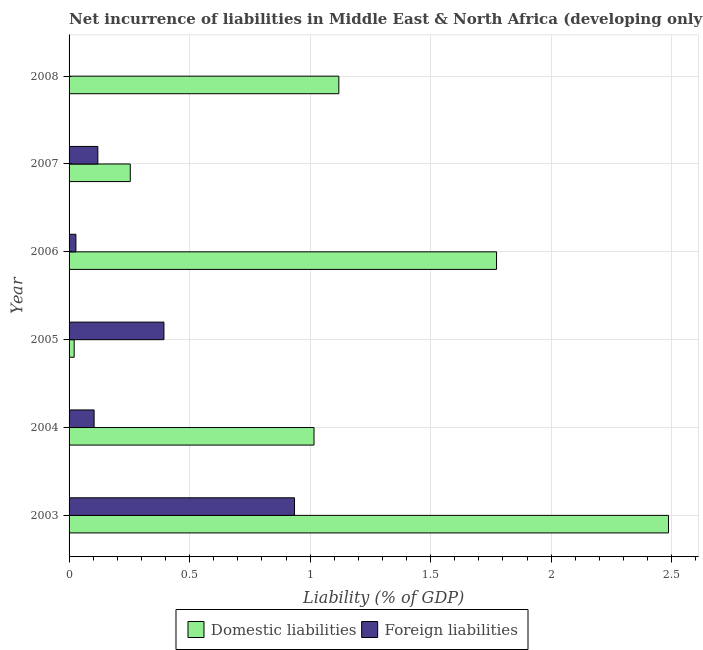How many different coloured bars are there?
Offer a very short reply. 2. How many bars are there on the 4th tick from the top?
Provide a short and direct response. 2. In how many cases, is the number of bars for a given year not equal to the number of legend labels?
Offer a terse response. 1. What is the incurrence of foreign liabilities in 2004?
Keep it short and to the point. 0.1. Across all years, what is the maximum incurrence of domestic liabilities?
Give a very brief answer. 2.49. Across all years, what is the minimum incurrence of domestic liabilities?
Make the answer very short. 0.02. In which year was the incurrence of domestic liabilities maximum?
Your answer should be very brief. 2003. What is the total incurrence of domestic liabilities in the graph?
Your response must be concise. 6.67. What is the difference between the incurrence of domestic liabilities in 2004 and that in 2007?
Give a very brief answer. 0.76. What is the difference between the incurrence of foreign liabilities in 2008 and the incurrence of domestic liabilities in 2005?
Your answer should be compact. -0.02. What is the average incurrence of domestic liabilities per year?
Your answer should be compact. 1.11. In the year 2003, what is the difference between the incurrence of domestic liabilities and incurrence of foreign liabilities?
Your answer should be compact. 1.55. In how many years, is the incurrence of domestic liabilities greater than 1.8 %?
Your answer should be compact. 1. What is the ratio of the incurrence of domestic liabilities in 2005 to that in 2007?
Keep it short and to the point. 0.08. Is the incurrence of foreign liabilities in 2004 less than that in 2006?
Your answer should be compact. No. What is the difference between the highest and the second highest incurrence of domestic liabilities?
Provide a succinct answer. 0.71. What is the difference between the highest and the lowest incurrence of domestic liabilities?
Your answer should be compact. 2.47. In how many years, is the incurrence of foreign liabilities greater than the average incurrence of foreign liabilities taken over all years?
Provide a succinct answer. 2. How many years are there in the graph?
Your answer should be compact. 6. What is the difference between two consecutive major ticks on the X-axis?
Offer a terse response. 0.5. Does the graph contain grids?
Your answer should be compact. Yes. Where does the legend appear in the graph?
Offer a very short reply. Bottom center. How are the legend labels stacked?
Offer a very short reply. Horizontal. What is the title of the graph?
Provide a succinct answer. Net incurrence of liabilities in Middle East & North Africa (developing only). What is the label or title of the X-axis?
Offer a very short reply. Liability (% of GDP). What is the label or title of the Y-axis?
Keep it short and to the point. Year. What is the Liability (% of GDP) of Domestic liabilities in 2003?
Offer a terse response. 2.49. What is the Liability (% of GDP) of Foreign liabilities in 2003?
Your answer should be compact. 0.94. What is the Liability (% of GDP) of Domestic liabilities in 2004?
Your answer should be compact. 1.02. What is the Liability (% of GDP) in Foreign liabilities in 2004?
Your answer should be compact. 0.1. What is the Liability (% of GDP) of Domestic liabilities in 2005?
Provide a succinct answer. 0.02. What is the Liability (% of GDP) of Foreign liabilities in 2005?
Make the answer very short. 0.39. What is the Liability (% of GDP) of Domestic liabilities in 2006?
Your answer should be compact. 1.77. What is the Liability (% of GDP) in Foreign liabilities in 2006?
Your answer should be compact. 0.03. What is the Liability (% of GDP) in Domestic liabilities in 2007?
Your answer should be compact. 0.25. What is the Liability (% of GDP) of Foreign liabilities in 2007?
Your response must be concise. 0.12. What is the Liability (% of GDP) of Domestic liabilities in 2008?
Provide a short and direct response. 1.12. Across all years, what is the maximum Liability (% of GDP) in Domestic liabilities?
Your response must be concise. 2.49. Across all years, what is the maximum Liability (% of GDP) in Foreign liabilities?
Your response must be concise. 0.94. Across all years, what is the minimum Liability (% of GDP) of Domestic liabilities?
Your response must be concise. 0.02. What is the total Liability (% of GDP) in Domestic liabilities in the graph?
Your response must be concise. 6.67. What is the total Liability (% of GDP) of Foreign liabilities in the graph?
Your answer should be compact. 1.58. What is the difference between the Liability (% of GDP) of Domestic liabilities in 2003 and that in 2004?
Your response must be concise. 1.47. What is the difference between the Liability (% of GDP) in Foreign liabilities in 2003 and that in 2004?
Keep it short and to the point. 0.83. What is the difference between the Liability (% of GDP) of Domestic liabilities in 2003 and that in 2005?
Ensure brevity in your answer.  2.47. What is the difference between the Liability (% of GDP) of Foreign liabilities in 2003 and that in 2005?
Your answer should be compact. 0.54. What is the difference between the Liability (% of GDP) in Domestic liabilities in 2003 and that in 2006?
Provide a short and direct response. 0.71. What is the difference between the Liability (% of GDP) in Foreign liabilities in 2003 and that in 2006?
Your answer should be compact. 0.91. What is the difference between the Liability (% of GDP) in Domestic liabilities in 2003 and that in 2007?
Offer a terse response. 2.23. What is the difference between the Liability (% of GDP) of Foreign liabilities in 2003 and that in 2007?
Make the answer very short. 0.82. What is the difference between the Liability (% of GDP) in Domestic liabilities in 2003 and that in 2008?
Your answer should be compact. 1.37. What is the difference between the Liability (% of GDP) of Domestic liabilities in 2004 and that in 2005?
Your answer should be very brief. 1. What is the difference between the Liability (% of GDP) of Foreign liabilities in 2004 and that in 2005?
Your answer should be very brief. -0.29. What is the difference between the Liability (% of GDP) in Domestic liabilities in 2004 and that in 2006?
Provide a short and direct response. -0.76. What is the difference between the Liability (% of GDP) in Foreign liabilities in 2004 and that in 2006?
Offer a very short reply. 0.08. What is the difference between the Liability (% of GDP) in Domestic liabilities in 2004 and that in 2007?
Your answer should be compact. 0.76. What is the difference between the Liability (% of GDP) in Foreign liabilities in 2004 and that in 2007?
Give a very brief answer. -0.02. What is the difference between the Liability (% of GDP) in Domestic liabilities in 2004 and that in 2008?
Provide a succinct answer. -0.1. What is the difference between the Liability (% of GDP) of Domestic liabilities in 2005 and that in 2006?
Provide a short and direct response. -1.75. What is the difference between the Liability (% of GDP) in Foreign liabilities in 2005 and that in 2006?
Offer a terse response. 0.37. What is the difference between the Liability (% of GDP) of Domestic liabilities in 2005 and that in 2007?
Your response must be concise. -0.23. What is the difference between the Liability (% of GDP) of Foreign liabilities in 2005 and that in 2007?
Your answer should be compact. 0.27. What is the difference between the Liability (% of GDP) of Domestic liabilities in 2005 and that in 2008?
Your answer should be compact. -1.1. What is the difference between the Liability (% of GDP) of Domestic liabilities in 2006 and that in 2007?
Offer a terse response. 1.52. What is the difference between the Liability (% of GDP) in Foreign liabilities in 2006 and that in 2007?
Provide a short and direct response. -0.09. What is the difference between the Liability (% of GDP) in Domestic liabilities in 2006 and that in 2008?
Keep it short and to the point. 0.65. What is the difference between the Liability (% of GDP) of Domestic liabilities in 2007 and that in 2008?
Your response must be concise. -0.87. What is the difference between the Liability (% of GDP) of Domestic liabilities in 2003 and the Liability (% of GDP) of Foreign liabilities in 2004?
Ensure brevity in your answer.  2.38. What is the difference between the Liability (% of GDP) in Domestic liabilities in 2003 and the Liability (% of GDP) in Foreign liabilities in 2005?
Provide a short and direct response. 2.09. What is the difference between the Liability (% of GDP) of Domestic liabilities in 2003 and the Liability (% of GDP) of Foreign liabilities in 2006?
Make the answer very short. 2.46. What is the difference between the Liability (% of GDP) of Domestic liabilities in 2003 and the Liability (% of GDP) of Foreign liabilities in 2007?
Your answer should be compact. 2.37. What is the difference between the Liability (% of GDP) in Domestic liabilities in 2004 and the Liability (% of GDP) in Foreign liabilities in 2005?
Make the answer very short. 0.62. What is the difference between the Liability (% of GDP) of Domestic liabilities in 2004 and the Liability (% of GDP) of Foreign liabilities in 2006?
Your response must be concise. 0.99. What is the difference between the Liability (% of GDP) in Domestic liabilities in 2004 and the Liability (% of GDP) in Foreign liabilities in 2007?
Provide a succinct answer. 0.9. What is the difference between the Liability (% of GDP) of Domestic liabilities in 2005 and the Liability (% of GDP) of Foreign liabilities in 2006?
Keep it short and to the point. -0.01. What is the difference between the Liability (% of GDP) of Domestic liabilities in 2005 and the Liability (% of GDP) of Foreign liabilities in 2007?
Provide a succinct answer. -0.1. What is the difference between the Liability (% of GDP) of Domestic liabilities in 2006 and the Liability (% of GDP) of Foreign liabilities in 2007?
Offer a very short reply. 1.65. What is the average Liability (% of GDP) of Domestic liabilities per year?
Your answer should be compact. 1.11. What is the average Liability (% of GDP) in Foreign liabilities per year?
Make the answer very short. 0.26. In the year 2003, what is the difference between the Liability (% of GDP) in Domestic liabilities and Liability (% of GDP) in Foreign liabilities?
Provide a short and direct response. 1.55. In the year 2004, what is the difference between the Liability (% of GDP) in Domestic liabilities and Liability (% of GDP) in Foreign liabilities?
Provide a short and direct response. 0.91. In the year 2005, what is the difference between the Liability (% of GDP) of Domestic liabilities and Liability (% of GDP) of Foreign liabilities?
Ensure brevity in your answer.  -0.37. In the year 2006, what is the difference between the Liability (% of GDP) of Domestic liabilities and Liability (% of GDP) of Foreign liabilities?
Ensure brevity in your answer.  1.75. In the year 2007, what is the difference between the Liability (% of GDP) of Domestic liabilities and Liability (% of GDP) of Foreign liabilities?
Give a very brief answer. 0.13. What is the ratio of the Liability (% of GDP) in Domestic liabilities in 2003 to that in 2004?
Keep it short and to the point. 2.45. What is the ratio of the Liability (% of GDP) in Foreign liabilities in 2003 to that in 2004?
Provide a succinct answer. 9.01. What is the ratio of the Liability (% of GDP) in Domestic liabilities in 2003 to that in 2005?
Your answer should be very brief. 117.13. What is the ratio of the Liability (% of GDP) in Foreign liabilities in 2003 to that in 2005?
Provide a succinct answer. 2.38. What is the ratio of the Liability (% of GDP) in Domestic liabilities in 2003 to that in 2006?
Make the answer very short. 1.4. What is the ratio of the Liability (% of GDP) in Foreign liabilities in 2003 to that in 2006?
Your answer should be compact. 32.97. What is the ratio of the Liability (% of GDP) of Domestic liabilities in 2003 to that in 2007?
Your answer should be very brief. 9.79. What is the ratio of the Liability (% of GDP) of Foreign liabilities in 2003 to that in 2007?
Provide a succinct answer. 7.84. What is the ratio of the Liability (% of GDP) in Domestic liabilities in 2003 to that in 2008?
Offer a very short reply. 2.22. What is the ratio of the Liability (% of GDP) of Domestic liabilities in 2004 to that in 2005?
Offer a very short reply. 47.86. What is the ratio of the Liability (% of GDP) of Foreign liabilities in 2004 to that in 2005?
Give a very brief answer. 0.26. What is the ratio of the Liability (% of GDP) in Domestic liabilities in 2004 to that in 2006?
Keep it short and to the point. 0.57. What is the ratio of the Liability (% of GDP) of Foreign liabilities in 2004 to that in 2006?
Provide a short and direct response. 3.66. What is the ratio of the Liability (% of GDP) of Domestic liabilities in 2004 to that in 2007?
Ensure brevity in your answer.  4. What is the ratio of the Liability (% of GDP) of Foreign liabilities in 2004 to that in 2007?
Your answer should be very brief. 0.87. What is the ratio of the Liability (% of GDP) of Domestic liabilities in 2004 to that in 2008?
Offer a very short reply. 0.91. What is the ratio of the Liability (% of GDP) of Domestic liabilities in 2005 to that in 2006?
Make the answer very short. 0.01. What is the ratio of the Liability (% of GDP) in Foreign liabilities in 2005 to that in 2006?
Your answer should be very brief. 13.87. What is the ratio of the Liability (% of GDP) in Domestic liabilities in 2005 to that in 2007?
Your answer should be compact. 0.08. What is the ratio of the Liability (% of GDP) in Foreign liabilities in 2005 to that in 2007?
Ensure brevity in your answer.  3.3. What is the ratio of the Liability (% of GDP) in Domestic liabilities in 2005 to that in 2008?
Keep it short and to the point. 0.02. What is the ratio of the Liability (% of GDP) of Domestic liabilities in 2006 to that in 2007?
Offer a terse response. 6.98. What is the ratio of the Liability (% of GDP) in Foreign liabilities in 2006 to that in 2007?
Give a very brief answer. 0.24. What is the ratio of the Liability (% of GDP) of Domestic liabilities in 2006 to that in 2008?
Ensure brevity in your answer.  1.58. What is the ratio of the Liability (% of GDP) of Domestic liabilities in 2007 to that in 2008?
Keep it short and to the point. 0.23. What is the difference between the highest and the second highest Liability (% of GDP) in Domestic liabilities?
Your response must be concise. 0.71. What is the difference between the highest and the second highest Liability (% of GDP) in Foreign liabilities?
Offer a very short reply. 0.54. What is the difference between the highest and the lowest Liability (% of GDP) of Domestic liabilities?
Make the answer very short. 2.47. What is the difference between the highest and the lowest Liability (% of GDP) of Foreign liabilities?
Offer a terse response. 0.94. 